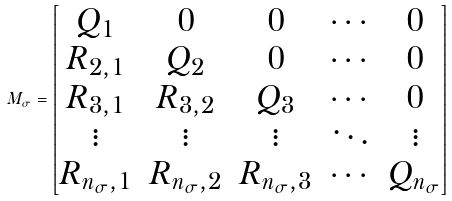<formula> <loc_0><loc_0><loc_500><loc_500>M _ { \sigma } = \begin{bmatrix} Q _ { 1 } & 0 & 0 & \cdots & 0 \\ R _ { 2 , 1 } & Q _ { 2 } & 0 & \cdots & 0 \\ R _ { 3 , 1 } & R _ { 3 , 2 } & Q _ { 3 } & \cdots & 0 \\ \vdots & \vdots & \vdots & \ddots & \vdots \\ R _ { n _ { \sigma } , 1 } & R _ { n _ { \sigma } , 2 } & R _ { n _ { \sigma } , 3 } & \cdots & Q _ { n _ { \sigma } } \end{bmatrix}</formula> 